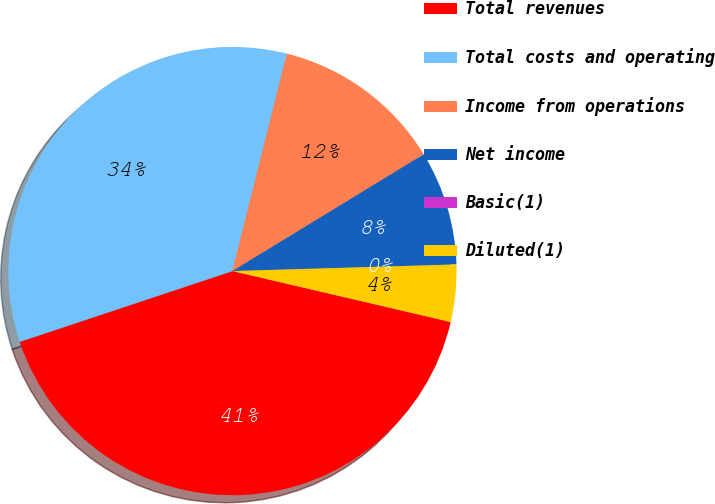Convert chart to OTSL. <chart><loc_0><loc_0><loc_500><loc_500><pie_chart><fcel>Total revenues<fcel>Total costs and operating<fcel>Income from operations<fcel>Net income<fcel>Basic(1)<fcel>Diluted(1)<nl><fcel>41.24%<fcel>34.02%<fcel>12.37%<fcel>8.25%<fcel>0.0%<fcel>4.12%<nl></chart> 